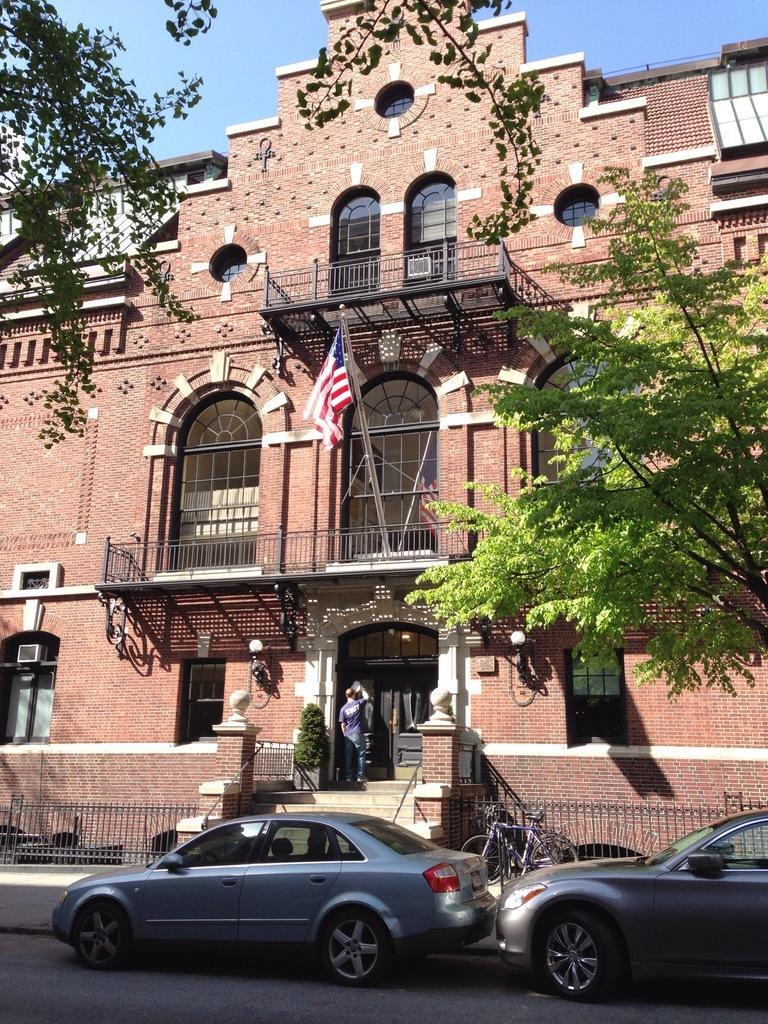In one or two sentences, can you explain what this image depicts? In this image we can see two cars which are parked on road, there is bicycle and there is a building to which there is some national flag and there is a person standing near the door which is black in color, there are some trees on left and right side of the image and top of the image there is clear sky. 